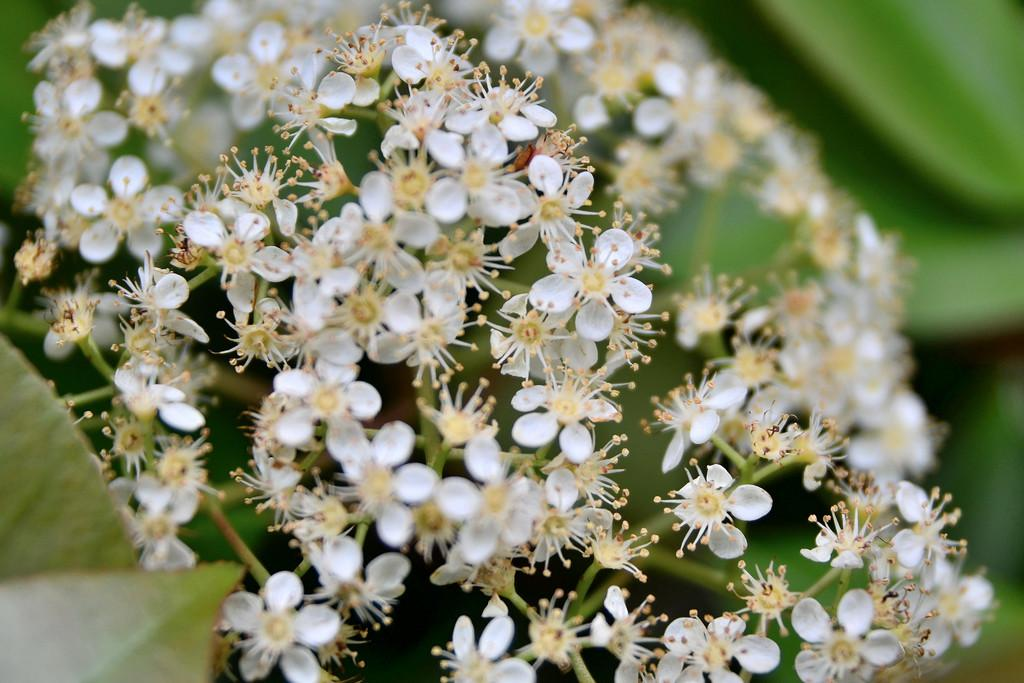What type of plants are visible in the image? There are flowers in the image. What color are the flowers? The flowers are white in color. What can be seen on the flowers in the image? There are pollen grains visible on the flowers in the image. What color are the pollen grains? The pollen grains are yellow in color. What type of vegetation is visible in the background of the image? There are green leaves in the background of the image. How many ducks are swimming in the liquid in the image? There are no ducks or liquid present in the image; it features flowers, pollen grains, and green leaves. What color is the eye of the person in the image? There is no person present in the image, so it is not possible to determine the color of their eye. 